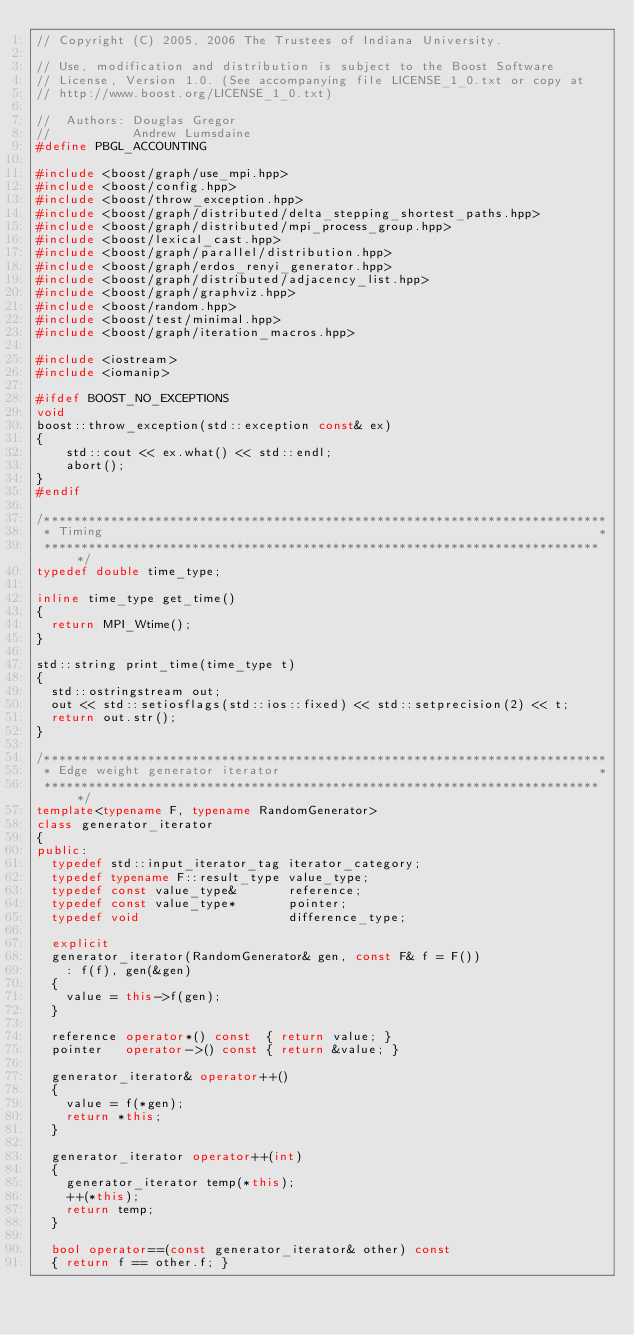Convert code to text. <code><loc_0><loc_0><loc_500><loc_500><_C++_>// Copyright (C) 2005, 2006 The Trustees of Indiana University.

// Use, modification and distribution is subject to the Boost Software
// License, Version 1.0. (See accompanying file LICENSE_1_0.txt or copy at
// http://www.boost.org/LICENSE_1_0.txt)

//  Authors: Douglas Gregor
//           Andrew Lumsdaine
#define PBGL_ACCOUNTING

#include <boost/graph/use_mpi.hpp>
#include <boost/config.hpp>
#include <boost/throw_exception.hpp>
#include <boost/graph/distributed/delta_stepping_shortest_paths.hpp>
#include <boost/graph/distributed/mpi_process_group.hpp>
#include <boost/lexical_cast.hpp>
#include <boost/graph/parallel/distribution.hpp>
#include <boost/graph/erdos_renyi_generator.hpp>
#include <boost/graph/distributed/adjacency_list.hpp>
#include <boost/graph/graphviz.hpp>
#include <boost/random.hpp>
#include <boost/test/minimal.hpp>
#include <boost/graph/iteration_macros.hpp>

#include <iostream>
#include <iomanip>

#ifdef BOOST_NO_EXCEPTIONS
void
boost::throw_exception(std::exception const& ex)
{
    std::cout << ex.what() << std::endl;
    abort();
}
#endif

/****************************************************************************
 * Timing                                                                   *
 ****************************************************************************/
typedef double time_type;

inline time_type get_time()
{
  return MPI_Wtime();
}

std::string print_time(time_type t)
{
  std::ostringstream out;
  out << std::setiosflags(std::ios::fixed) << std::setprecision(2) << t;
  return out.str();
}

/****************************************************************************
 * Edge weight generator iterator                                           *
 ****************************************************************************/
template<typename F, typename RandomGenerator>
class generator_iterator
{
public:
  typedef std::input_iterator_tag iterator_category;
  typedef typename F::result_type value_type;
  typedef const value_type&       reference;
  typedef const value_type*       pointer;
  typedef void                    difference_type;

  explicit 
  generator_iterator(RandomGenerator& gen, const F& f = F()) 
    : f(f), gen(&gen) 
  { 
    value = this->f(gen); 
  }

  reference operator*() const  { return value; }
  pointer   operator->() const { return &value; }

  generator_iterator& operator++()
  {
    value = f(*gen);
    return *this;
  }

  generator_iterator operator++(int)
  {
    generator_iterator temp(*this);
    ++(*this);
    return temp;
  }

  bool operator==(const generator_iterator& other) const
  { return f == other.f; }
</code> 